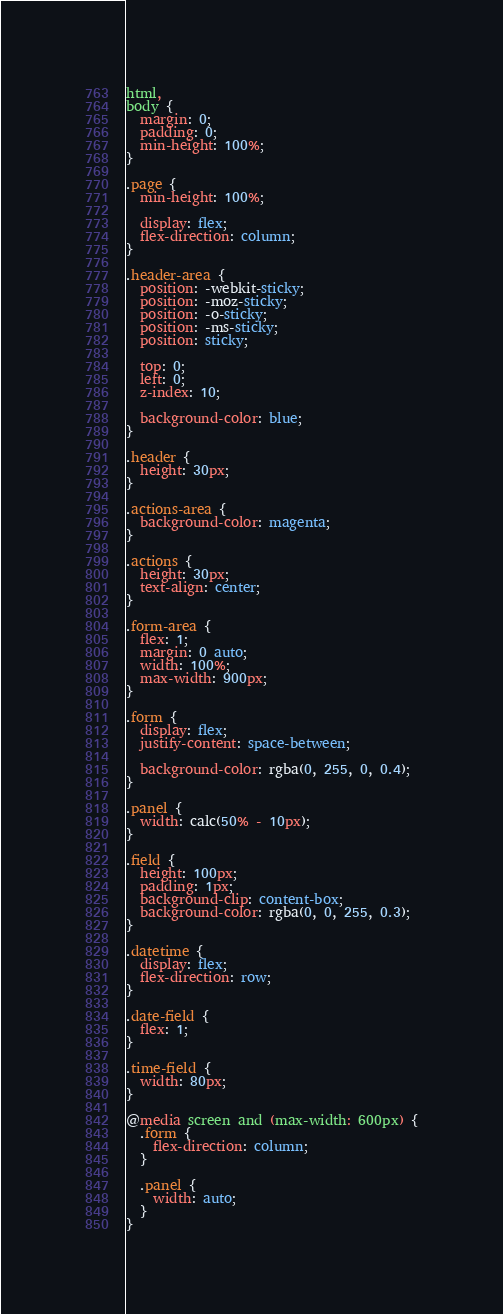Convert code to text. <code><loc_0><loc_0><loc_500><loc_500><_CSS_>html,
body {
  margin: 0;
  padding: 0;
  min-height: 100%;
}

.page {
  min-height: 100%;

  display: flex;
  flex-direction: column;
}

.header-area {
  position: -webkit-sticky;
  position: -moz-sticky;
  position: -o-sticky;
  position: -ms-sticky;
  position: sticky;

  top: 0;
  left: 0;
  z-index: 10;

  background-color: blue;
}

.header {
  height: 30px;
}

.actions-area {
  background-color: magenta;
}

.actions {
  height: 30px;
  text-align: center;
}

.form-area {
  flex: 1;
  margin: 0 auto;
  width: 100%;
  max-width: 900px;
}

.form {
  display: flex;
  justify-content: space-between;

  background-color: rgba(0, 255, 0, 0.4);
}

.panel {
  width: calc(50% - 10px);
}

.field {
  height: 100px;
  padding: 1px;
  background-clip: content-box;
  background-color: rgba(0, 0, 255, 0.3);
}

.datetime {
  display: flex;
  flex-direction: row;
}

.date-field {
  flex: 1;
}

.time-field {
  width: 80px;
}

@media screen and (max-width: 600px) {
  .form {
    flex-direction: column;
  }

  .panel {
    width: auto;
  }
}
</code> 